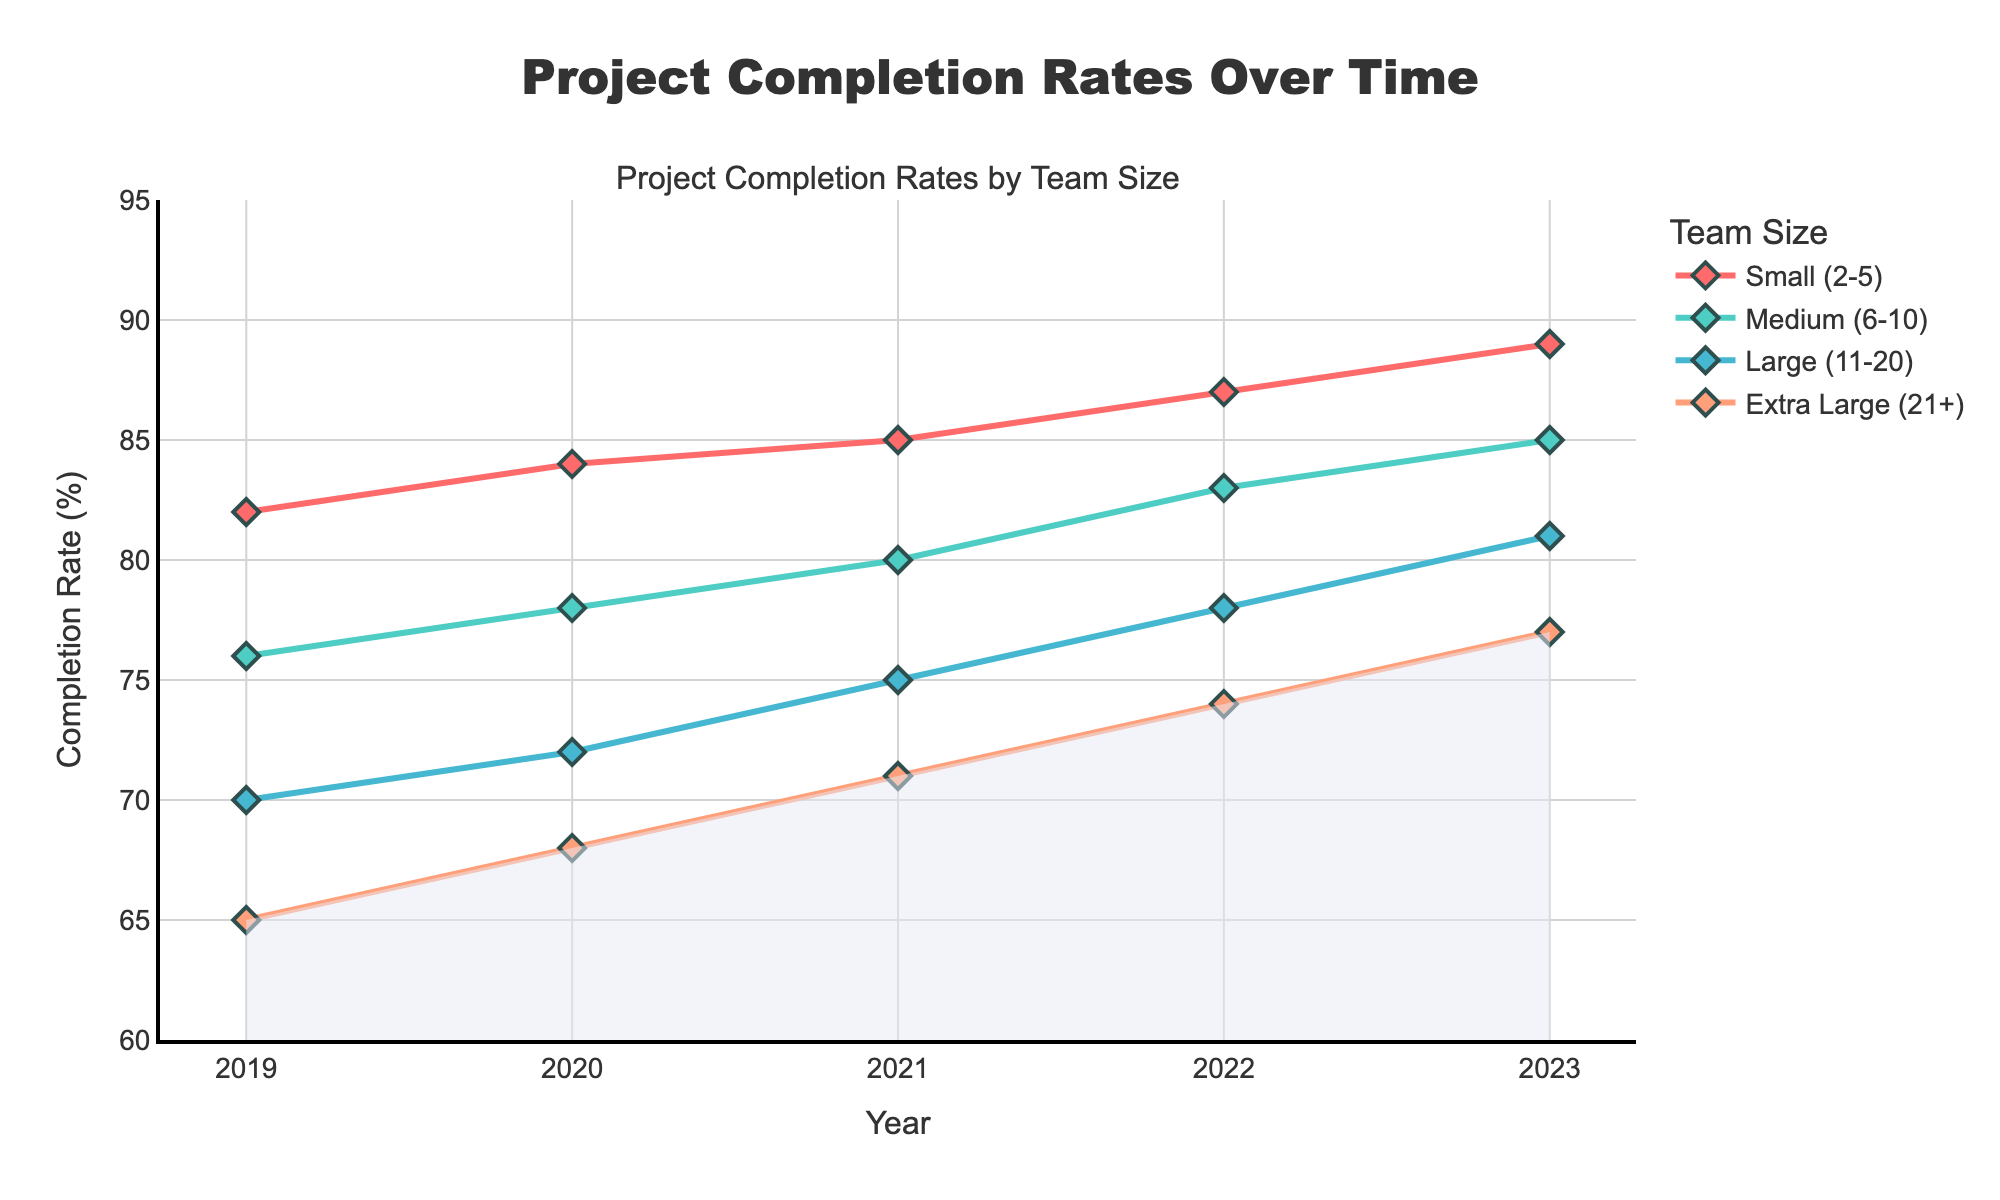Which team size saw the highest project completion rate in 2023? Look at the end points for 2023 on the graph and identify the highest y-value. This is for the Small (2-5) team size at 89%.
Answer: Small (2-5) How much did the project completion rate for the Extra Large (21+) team size increase from 2019 to 2023? Subtract the 2019 completion rate from the 2023 rate for the Extra Large (21+) team size: 77% - 65%. The increase is 12%.
Answer: 12% Which team size experienced the most consistent improvement in project completion rates over the years? Identify which line on the graph has the most uniform upward slope. The Small (2-5) team size shows a steady increase from 82% in 2019 to 89% in 2023.
Answer: Small (2-5) In 2021, which team size had the lowest completion rate and what was that rate? Locate the 2021 completion rates and find the lowest value. It is the Extra Large (21+) team size with a completion rate of 71%.
Answer: Extra Large (21+), 71% What's the average completion rate for the Medium (6-10) team size from 2019 to 2023? Calculate the average by summing the completion rates for the Medium (6-10) team size across the years (76 + 78 + 80 + 83 + 85) and divide by the number of years (5). (76 + 78 + 80 + 83 + 85) / 5 = 80.4.
Answer: 80.4 What is the difference in completion rate between the Small (2-5) and Large (11-20) team sizes in 2022? Subtract the 2022 rate for Large (11-20) from Small (2-5): 87% - 78%. The difference is 9%.
Answer: 9% Which team size had the largest increase in completion rate between 2021 and 2023? Find the difference in completion rates for each team size from 2021 to 2023 and identify the largest. For Extra Large (21+): 77 - 71 = 6%, for Large (11-20): 81 - 75 = 6%, for Medium (6-10): 85 - 80 = 5%, for Small (2-5): 89 - 85 = 4%. The Extra Large (21+) and Large (11-20) both had the largest increase of 6%.
Answer: Extra Large (21+), Large (11-20) How did the completion rate trend for the Small (2-5) team size from 2019 to 2023 compare to the Extra Large (21+) team size? Observe the trend lines for the two team sizes over the given years. Small (2-5) consistently rises from 82% in 2019 to 89% in 2023. Extra Large (21+) trends upwards from 65% in 2019 to 77% in 2023 but starts lower and ends lower.
Answer: Small (2-5) consistently higher and more stable Which team size shows the steepest slope of improvement between any two consecutive years? Identify the steepest segment on any of the lines. The steepest increase occurs for Extra Large (21+), which increased from 65% to 68% between 2019 to 2020 and from 68% to 71% between 2020 to 2021 (both by 3%).
Answer: Extra Large (21+) What is the range of completion rates for the Large (11-20) team size from 2019 to 2023? Identify the highest and lowest completion rates for the Large (11-20) group: highest is 81% in 2023, and lowest is 70% in 2019. Range is the difference: 81% - 70%.
Answer: 11% 